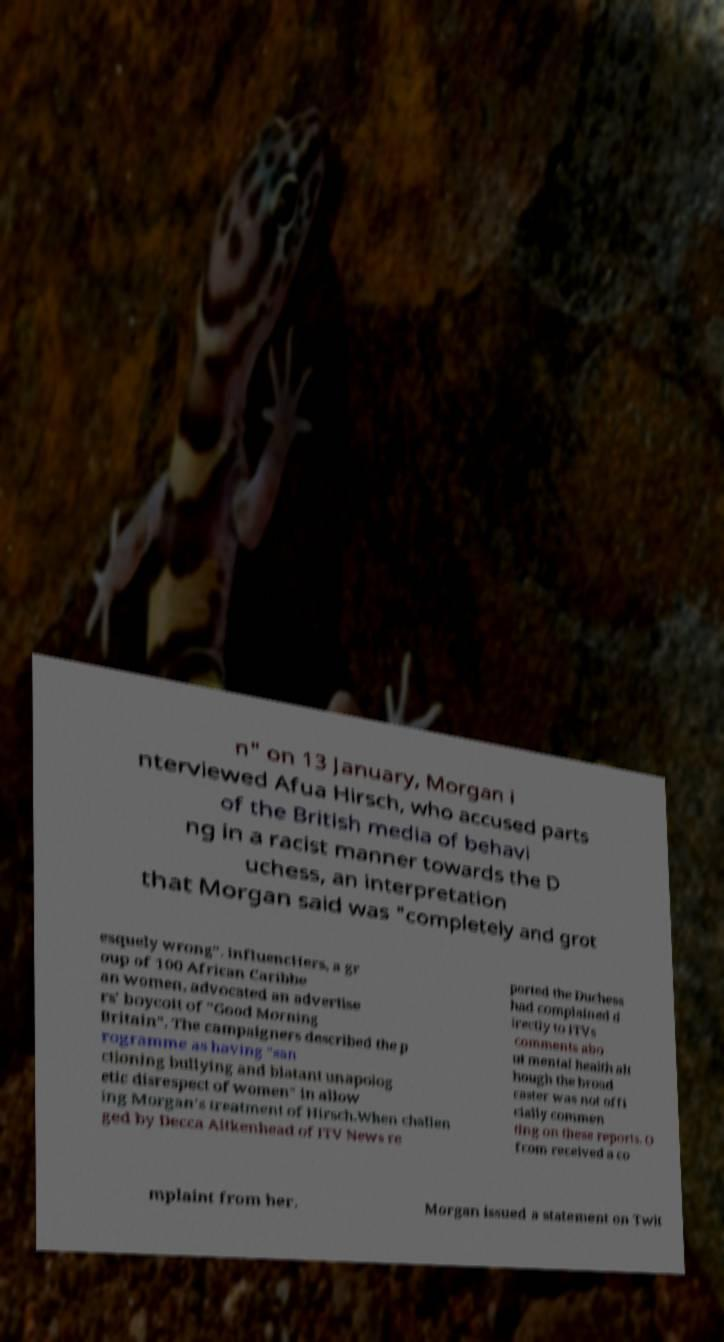Can you accurately transcribe the text from the provided image for me? n" on 13 January, Morgan i nterviewed Afua Hirsch, who accused parts of the British media of behavi ng in a racist manner towards the D uchess, an interpretation that Morgan said was "completely and grot esquely wrong". InfluencHers, a gr oup of 100 African Caribbe an women, advocated an advertise rs' boycott of "Good Morning Britain". The campaigners described the p rogramme as having "san ctioning bullying and blatant unapolog etic disrespect of women" in allow ing Morgan's treatment of Hirsch.When challen ged by Decca Aitkenhead of ITV News re ported the Duchess had complained d irectly to ITVs comments abo ut mental health alt hough the broad caster was not offi cially commen ting on these reports. O fcom received a co mplaint from her. Morgan issued a statement on Twit 